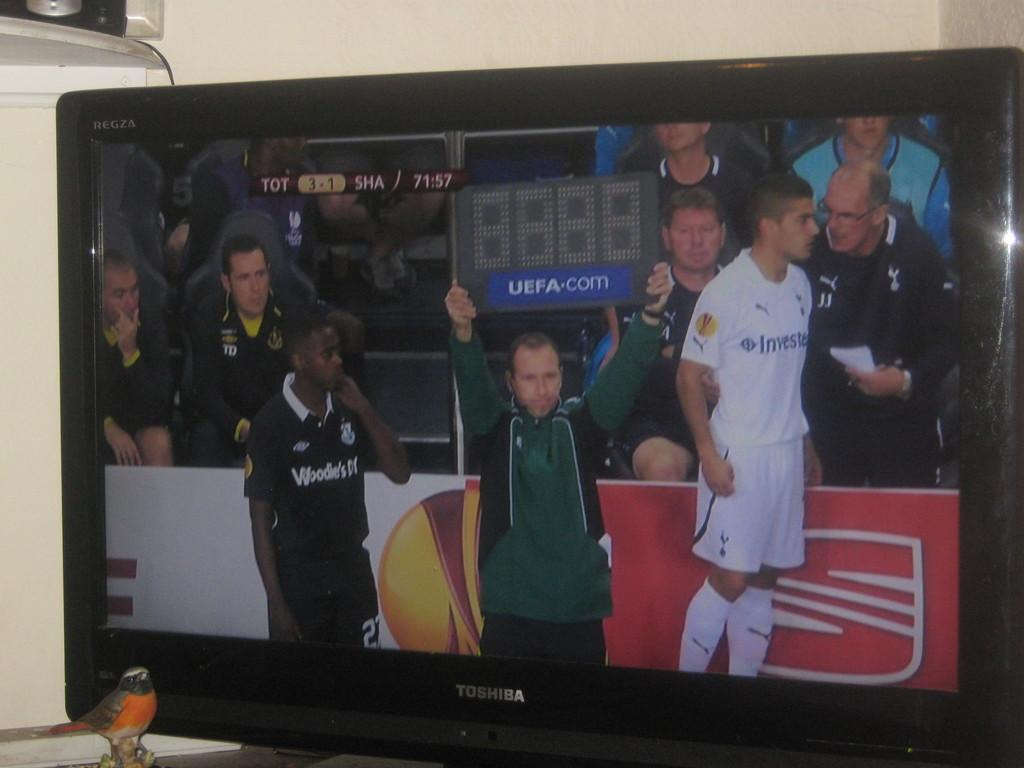<image>
Summarize the visual content of the image. The score displayed is TOT 3 to SHA 1 